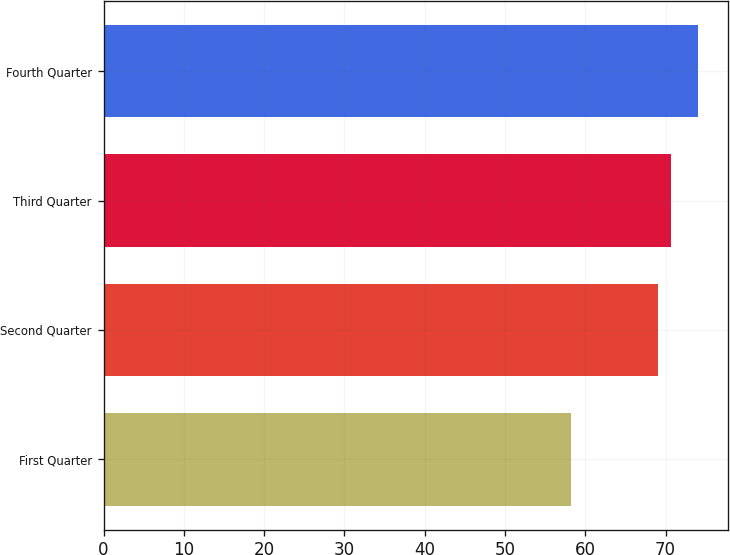<chart> <loc_0><loc_0><loc_500><loc_500><bar_chart><fcel>First Quarter<fcel>Second Quarter<fcel>Third Quarter<fcel>Fourth Quarter<nl><fcel>58.24<fcel>69.07<fcel>70.65<fcel>74.09<nl></chart> 